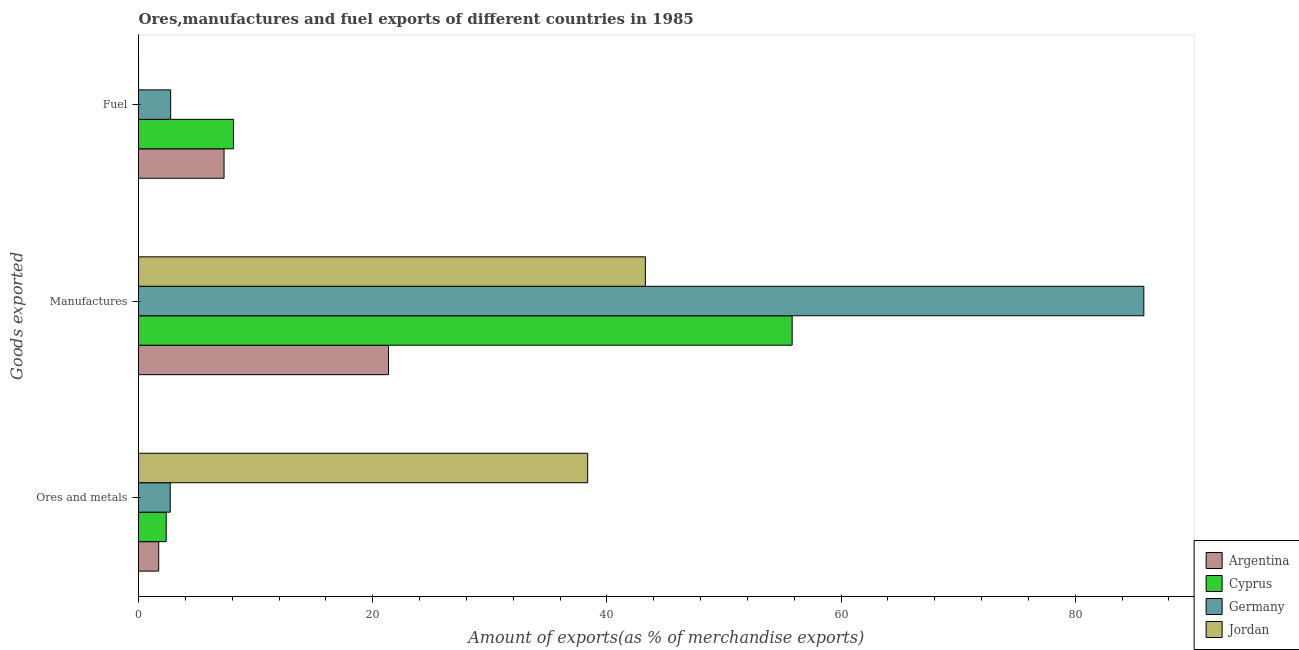How many different coloured bars are there?
Give a very brief answer. 4. How many groups of bars are there?
Offer a very short reply. 3. Are the number of bars on each tick of the Y-axis equal?
Give a very brief answer. Yes. How many bars are there on the 1st tick from the top?
Your answer should be very brief. 4. How many bars are there on the 1st tick from the bottom?
Your answer should be very brief. 4. What is the label of the 3rd group of bars from the top?
Give a very brief answer. Ores and metals. What is the percentage of manufactures exports in Argentina?
Give a very brief answer. 21.35. Across all countries, what is the maximum percentage of manufactures exports?
Give a very brief answer. 85.86. Across all countries, what is the minimum percentage of ores and metals exports?
Ensure brevity in your answer.  1.72. In which country was the percentage of fuel exports maximum?
Provide a succinct answer. Cyprus. What is the total percentage of fuel exports in the graph?
Your response must be concise. 18.16. What is the difference between the percentage of fuel exports in Germany and that in Cyprus?
Your response must be concise. -5.36. What is the difference between the percentage of manufactures exports in Jordan and the percentage of fuel exports in Argentina?
Keep it short and to the point. 35.98. What is the average percentage of ores and metals exports per country?
Provide a succinct answer. 11.29. What is the difference between the percentage of ores and metals exports and percentage of fuel exports in Germany?
Provide a succinct answer. -0.04. In how many countries, is the percentage of fuel exports greater than 56 %?
Provide a succinct answer. 0. What is the ratio of the percentage of fuel exports in Germany to that in Jordan?
Offer a very short reply. 876.06. Is the percentage of fuel exports in Cyprus less than that in Argentina?
Provide a short and direct response. No. Is the difference between the percentage of manufactures exports in Argentina and Germany greater than the difference between the percentage of fuel exports in Argentina and Germany?
Give a very brief answer. No. What is the difference between the highest and the second highest percentage of ores and metals exports?
Your answer should be compact. 35.66. What is the difference between the highest and the lowest percentage of fuel exports?
Make the answer very short. 8.1. Is the sum of the percentage of fuel exports in Argentina and Jordan greater than the maximum percentage of manufactures exports across all countries?
Provide a succinct answer. No. What does the 4th bar from the top in Manufactures represents?
Give a very brief answer. Argentina. What does the 4th bar from the bottom in Fuel represents?
Give a very brief answer. Jordan. How many countries are there in the graph?
Give a very brief answer. 4. What is the difference between two consecutive major ticks on the X-axis?
Provide a short and direct response. 20. What is the title of the graph?
Ensure brevity in your answer.  Ores,manufactures and fuel exports of different countries in 1985. What is the label or title of the X-axis?
Make the answer very short. Amount of exports(as % of merchandise exports). What is the label or title of the Y-axis?
Your answer should be compact. Goods exported. What is the Amount of exports(as % of merchandise exports) of Argentina in Ores and metals?
Your answer should be compact. 1.72. What is the Amount of exports(as % of merchandise exports) in Cyprus in Ores and metals?
Ensure brevity in your answer.  2.37. What is the Amount of exports(as % of merchandise exports) of Germany in Ores and metals?
Offer a terse response. 2.71. What is the Amount of exports(as % of merchandise exports) of Jordan in Ores and metals?
Your response must be concise. 38.36. What is the Amount of exports(as % of merchandise exports) of Argentina in Manufactures?
Your response must be concise. 21.35. What is the Amount of exports(as % of merchandise exports) of Cyprus in Manufactures?
Your answer should be very brief. 55.83. What is the Amount of exports(as % of merchandise exports) in Germany in Manufactures?
Provide a short and direct response. 85.86. What is the Amount of exports(as % of merchandise exports) in Jordan in Manufactures?
Give a very brief answer. 43.29. What is the Amount of exports(as % of merchandise exports) of Argentina in Fuel?
Ensure brevity in your answer.  7.31. What is the Amount of exports(as % of merchandise exports) of Cyprus in Fuel?
Give a very brief answer. 8.11. What is the Amount of exports(as % of merchandise exports) in Germany in Fuel?
Give a very brief answer. 2.74. What is the Amount of exports(as % of merchandise exports) in Jordan in Fuel?
Your response must be concise. 0. Across all Goods exported, what is the maximum Amount of exports(as % of merchandise exports) in Argentina?
Give a very brief answer. 21.35. Across all Goods exported, what is the maximum Amount of exports(as % of merchandise exports) in Cyprus?
Your answer should be compact. 55.83. Across all Goods exported, what is the maximum Amount of exports(as % of merchandise exports) of Germany?
Offer a very short reply. 85.86. Across all Goods exported, what is the maximum Amount of exports(as % of merchandise exports) in Jordan?
Ensure brevity in your answer.  43.29. Across all Goods exported, what is the minimum Amount of exports(as % of merchandise exports) of Argentina?
Offer a very short reply. 1.72. Across all Goods exported, what is the minimum Amount of exports(as % of merchandise exports) in Cyprus?
Your answer should be compact. 2.37. Across all Goods exported, what is the minimum Amount of exports(as % of merchandise exports) in Germany?
Offer a terse response. 2.71. Across all Goods exported, what is the minimum Amount of exports(as % of merchandise exports) in Jordan?
Provide a short and direct response. 0. What is the total Amount of exports(as % of merchandise exports) of Argentina in the graph?
Ensure brevity in your answer.  30.38. What is the total Amount of exports(as % of merchandise exports) in Cyprus in the graph?
Give a very brief answer. 66.3. What is the total Amount of exports(as % of merchandise exports) in Germany in the graph?
Your answer should be compact. 91.31. What is the total Amount of exports(as % of merchandise exports) in Jordan in the graph?
Ensure brevity in your answer.  81.66. What is the difference between the Amount of exports(as % of merchandise exports) of Argentina in Ores and metals and that in Manufactures?
Offer a terse response. -19.63. What is the difference between the Amount of exports(as % of merchandise exports) in Cyprus in Ores and metals and that in Manufactures?
Your answer should be compact. -53.46. What is the difference between the Amount of exports(as % of merchandise exports) in Germany in Ores and metals and that in Manufactures?
Offer a terse response. -83.15. What is the difference between the Amount of exports(as % of merchandise exports) of Jordan in Ores and metals and that in Manufactures?
Provide a short and direct response. -4.93. What is the difference between the Amount of exports(as % of merchandise exports) in Argentina in Ores and metals and that in Fuel?
Your answer should be compact. -5.58. What is the difference between the Amount of exports(as % of merchandise exports) of Cyprus in Ores and metals and that in Fuel?
Offer a terse response. -5.74. What is the difference between the Amount of exports(as % of merchandise exports) in Germany in Ores and metals and that in Fuel?
Offer a very short reply. -0.04. What is the difference between the Amount of exports(as % of merchandise exports) in Jordan in Ores and metals and that in Fuel?
Your answer should be compact. 38.36. What is the difference between the Amount of exports(as % of merchandise exports) in Argentina in Manufactures and that in Fuel?
Your answer should be compact. 14.05. What is the difference between the Amount of exports(as % of merchandise exports) of Cyprus in Manufactures and that in Fuel?
Ensure brevity in your answer.  47.72. What is the difference between the Amount of exports(as % of merchandise exports) of Germany in Manufactures and that in Fuel?
Your response must be concise. 83.12. What is the difference between the Amount of exports(as % of merchandise exports) of Jordan in Manufactures and that in Fuel?
Offer a terse response. 43.29. What is the difference between the Amount of exports(as % of merchandise exports) of Argentina in Ores and metals and the Amount of exports(as % of merchandise exports) of Cyprus in Manufactures?
Give a very brief answer. -54.1. What is the difference between the Amount of exports(as % of merchandise exports) in Argentina in Ores and metals and the Amount of exports(as % of merchandise exports) in Germany in Manufactures?
Provide a short and direct response. -84.14. What is the difference between the Amount of exports(as % of merchandise exports) of Argentina in Ores and metals and the Amount of exports(as % of merchandise exports) of Jordan in Manufactures?
Provide a succinct answer. -41.57. What is the difference between the Amount of exports(as % of merchandise exports) in Cyprus in Ores and metals and the Amount of exports(as % of merchandise exports) in Germany in Manufactures?
Offer a very short reply. -83.5. What is the difference between the Amount of exports(as % of merchandise exports) in Cyprus in Ores and metals and the Amount of exports(as % of merchandise exports) in Jordan in Manufactures?
Your answer should be compact. -40.92. What is the difference between the Amount of exports(as % of merchandise exports) of Germany in Ores and metals and the Amount of exports(as % of merchandise exports) of Jordan in Manufactures?
Make the answer very short. -40.58. What is the difference between the Amount of exports(as % of merchandise exports) in Argentina in Ores and metals and the Amount of exports(as % of merchandise exports) in Cyprus in Fuel?
Offer a terse response. -6.38. What is the difference between the Amount of exports(as % of merchandise exports) in Argentina in Ores and metals and the Amount of exports(as % of merchandise exports) in Germany in Fuel?
Your response must be concise. -1.02. What is the difference between the Amount of exports(as % of merchandise exports) of Argentina in Ores and metals and the Amount of exports(as % of merchandise exports) of Jordan in Fuel?
Your response must be concise. 1.72. What is the difference between the Amount of exports(as % of merchandise exports) of Cyprus in Ores and metals and the Amount of exports(as % of merchandise exports) of Germany in Fuel?
Provide a short and direct response. -0.38. What is the difference between the Amount of exports(as % of merchandise exports) in Cyprus in Ores and metals and the Amount of exports(as % of merchandise exports) in Jordan in Fuel?
Offer a very short reply. 2.36. What is the difference between the Amount of exports(as % of merchandise exports) of Germany in Ores and metals and the Amount of exports(as % of merchandise exports) of Jordan in Fuel?
Provide a short and direct response. 2.7. What is the difference between the Amount of exports(as % of merchandise exports) in Argentina in Manufactures and the Amount of exports(as % of merchandise exports) in Cyprus in Fuel?
Your answer should be compact. 13.25. What is the difference between the Amount of exports(as % of merchandise exports) in Argentina in Manufactures and the Amount of exports(as % of merchandise exports) in Germany in Fuel?
Ensure brevity in your answer.  18.61. What is the difference between the Amount of exports(as % of merchandise exports) in Argentina in Manufactures and the Amount of exports(as % of merchandise exports) in Jordan in Fuel?
Your response must be concise. 21.35. What is the difference between the Amount of exports(as % of merchandise exports) in Cyprus in Manufactures and the Amount of exports(as % of merchandise exports) in Germany in Fuel?
Your answer should be very brief. 53.08. What is the difference between the Amount of exports(as % of merchandise exports) in Cyprus in Manufactures and the Amount of exports(as % of merchandise exports) in Jordan in Fuel?
Your answer should be compact. 55.82. What is the difference between the Amount of exports(as % of merchandise exports) of Germany in Manufactures and the Amount of exports(as % of merchandise exports) of Jordan in Fuel?
Offer a terse response. 85.86. What is the average Amount of exports(as % of merchandise exports) of Argentina per Goods exported?
Your answer should be very brief. 10.13. What is the average Amount of exports(as % of merchandise exports) in Cyprus per Goods exported?
Provide a succinct answer. 22.1. What is the average Amount of exports(as % of merchandise exports) in Germany per Goods exported?
Give a very brief answer. 30.44. What is the average Amount of exports(as % of merchandise exports) in Jordan per Goods exported?
Offer a very short reply. 27.22. What is the difference between the Amount of exports(as % of merchandise exports) in Argentina and Amount of exports(as % of merchandise exports) in Cyprus in Ores and metals?
Your answer should be compact. -0.64. What is the difference between the Amount of exports(as % of merchandise exports) in Argentina and Amount of exports(as % of merchandise exports) in Germany in Ores and metals?
Provide a short and direct response. -0.98. What is the difference between the Amount of exports(as % of merchandise exports) in Argentina and Amount of exports(as % of merchandise exports) in Jordan in Ores and metals?
Make the answer very short. -36.64. What is the difference between the Amount of exports(as % of merchandise exports) in Cyprus and Amount of exports(as % of merchandise exports) in Germany in Ores and metals?
Provide a short and direct response. -0.34. What is the difference between the Amount of exports(as % of merchandise exports) in Cyprus and Amount of exports(as % of merchandise exports) in Jordan in Ores and metals?
Provide a succinct answer. -36. What is the difference between the Amount of exports(as % of merchandise exports) in Germany and Amount of exports(as % of merchandise exports) in Jordan in Ores and metals?
Ensure brevity in your answer.  -35.66. What is the difference between the Amount of exports(as % of merchandise exports) of Argentina and Amount of exports(as % of merchandise exports) of Cyprus in Manufactures?
Ensure brevity in your answer.  -34.47. What is the difference between the Amount of exports(as % of merchandise exports) of Argentina and Amount of exports(as % of merchandise exports) of Germany in Manufactures?
Ensure brevity in your answer.  -64.51. What is the difference between the Amount of exports(as % of merchandise exports) in Argentina and Amount of exports(as % of merchandise exports) in Jordan in Manufactures?
Offer a very short reply. -21.94. What is the difference between the Amount of exports(as % of merchandise exports) of Cyprus and Amount of exports(as % of merchandise exports) of Germany in Manufactures?
Your answer should be compact. -30.04. What is the difference between the Amount of exports(as % of merchandise exports) of Cyprus and Amount of exports(as % of merchandise exports) of Jordan in Manufactures?
Give a very brief answer. 12.54. What is the difference between the Amount of exports(as % of merchandise exports) in Germany and Amount of exports(as % of merchandise exports) in Jordan in Manufactures?
Ensure brevity in your answer.  42.57. What is the difference between the Amount of exports(as % of merchandise exports) of Argentina and Amount of exports(as % of merchandise exports) of Cyprus in Fuel?
Offer a terse response. -0.8. What is the difference between the Amount of exports(as % of merchandise exports) in Argentina and Amount of exports(as % of merchandise exports) in Germany in Fuel?
Ensure brevity in your answer.  4.56. What is the difference between the Amount of exports(as % of merchandise exports) in Argentina and Amount of exports(as % of merchandise exports) in Jordan in Fuel?
Your answer should be compact. 7.3. What is the difference between the Amount of exports(as % of merchandise exports) in Cyprus and Amount of exports(as % of merchandise exports) in Germany in Fuel?
Provide a succinct answer. 5.36. What is the difference between the Amount of exports(as % of merchandise exports) of Cyprus and Amount of exports(as % of merchandise exports) of Jordan in Fuel?
Offer a very short reply. 8.1. What is the difference between the Amount of exports(as % of merchandise exports) in Germany and Amount of exports(as % of merchandise exports) in Jordan in Fuel?
Keep it short and to the point. 2.74. What is the ratio of the Amount of exports(as % of merchandise exports) in Argentina in Ores and metals to that in Manufactures?
Offer a very short reply. 0.08. What is the ratio of the Amount of exports(as % of merchandise exports) of Cyprus in Ores and metals to that in Manufactures?
Provide a succinct answer. 0.04. What is the ratio of the Amount of exports(as % of merchandise exports) of Germany in Ores and metals to that in Manufactures?
Keep it short and to the point. 0.03. What is the ratio of the Amount of exports(as % of merchandise exports) in Jordan in Ores and metals to that in Manufactures?
Offer a very short reply. 0.89. What is the ratio of the Amount of exports(as % of merchandise exports) of Argentina in Ores and metals to that in Fuel?
Your answer should be compact. 0.24. What is the ratio of the Amount of exports(as % of merchandise exports) in Cyprus in Ores and metals to that in Fuel?
Provide a short and direct response. 0.29. What is the ratio of the Amount of exports(as % of merchandise exports) in Germany in Ores and metals to that in Fuel?
Provide a short and direct response. 0.99. What is the ratio of the Amount of exports(as % of merchandise exports) of Jordan in Ores and metals to that in Fuel?
Provide a succinct answer. 1.22e+04. What is the ratio of the Amount of exports(as % of merchandise exports) in Argentina in Manufactures to that in Fuel?
Offer a terse response. 2.92. What is the ratio of the Amount of exports(as % of merchandise exports) in Cyprus in Manufactures to that in Fuel?
Your answer should be very brief. 6.89. What is the ratio of the Amount of exports(as % of merchandise exports) of Germany in Manufactures to that in Fuel?
Offer a terse response. 31.29. What is the ratio of the Amount of exports(as % of merchandise exports) in Jordan in Manufactures to that in Fuel?
Make the answer very short. 1.38e+04. What is the difference between the highest and the second highest Amount of exports(as % of merchandise exports) of Argentina?
Make the answer very short. 14.05. What is the difference between the highest and the second highest Amount of exports(as % of merchandise exports) of Cyprus?
Give a very brief answer. 47.72. What is the difference between the highest and the second highest Amount of exports(as % of merchandise exports) in Germany?
Your response must be concise. 83.12. What is the difference between the highest and the second highest Amount of exports(as % of merchandise exports) in Jordan?
Your answer should be very brief. 4.93. What is the difference between the highest and the lowest Amount of exports(as % of merchandise exports) in Argentina?
Offer a very short reply. 19.63. What is the difference between the highest and the lowest Amount of exports(as % of merchandise exports) in Cyprus?
Your answer should be compact. 53.46. What is the difference between the highest and the lowest Amount of exports(as % of merchandise exports) in Germany?
Your response must be concise. 83.15. What is the difference between the highest and the lowest Amount of exports(as % of merchandise exports) in Jordan?
Keep it short and to the point. 43.29. 